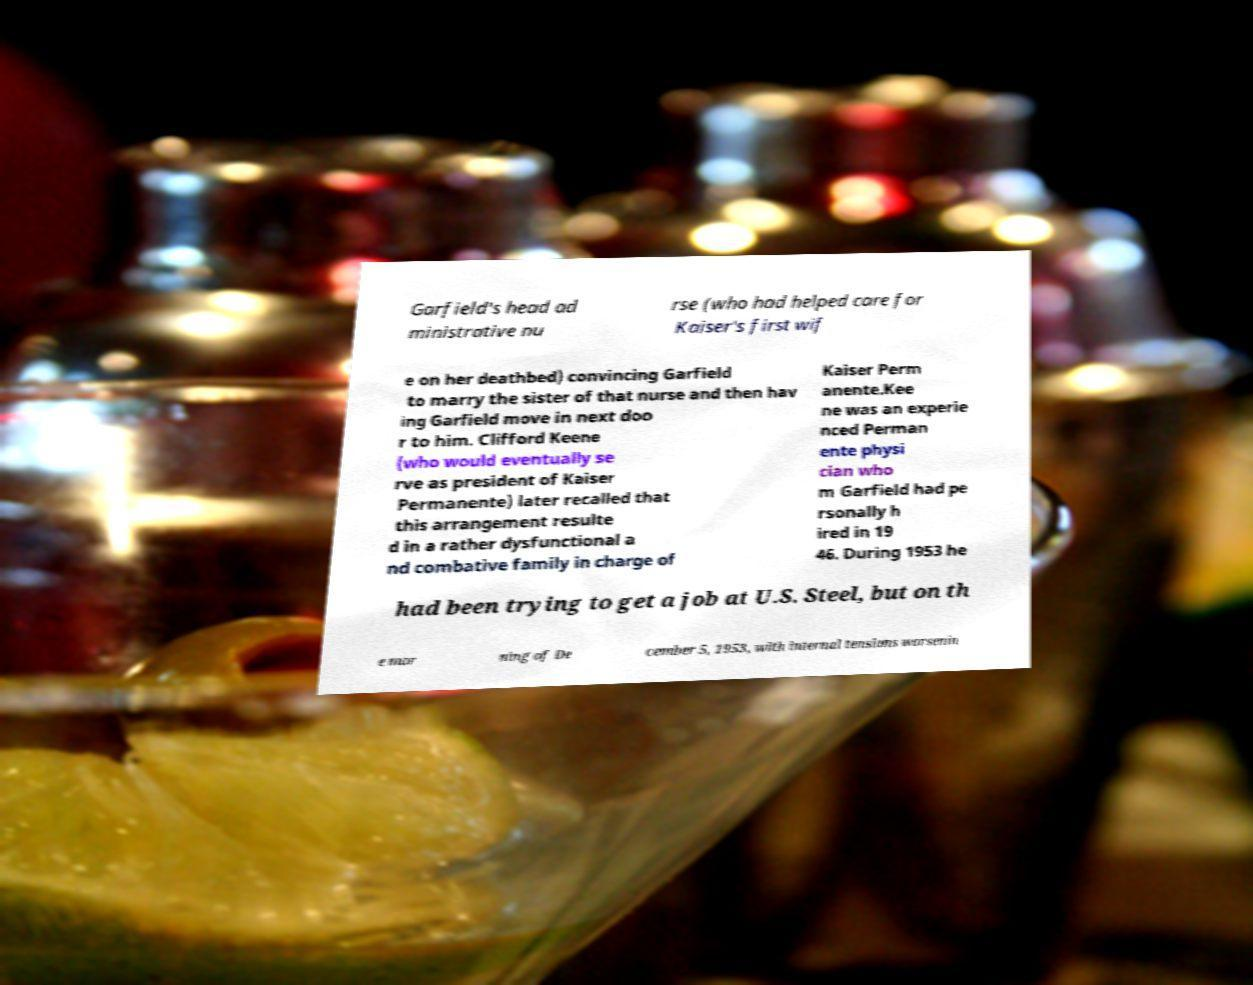Can you read and provide the text displayed in the image?This photo seems to have some interesting text. Can you extract and type it out for me? Garfield's head ad ministrative nu rse (who had helped care for Kaiser's first wif e on her deathbed) convincing Garfield to marry the sister of that nurse and then hav ing Garfield move in next doo r to him. Clifford Keene (who would eventually se rve as president of Kaiser Permanente) later recalled that this arrangement resulte d in a rather dysfunctional a nd combative family in charge of Kaiser Perm anente.Kee ne was an experie nced Perman ente physi cian who m Garfield had pe rsonally h ired in 19 46. During 1953 he had been trying to get a job at U.S. Steel, but on th e mor ning of De cember 5, 1953, with internal tensions worsenin 